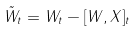Convert formula to latex. <formula><loc_0><loc_0><loc_500><loc_500>\tilde { W } _ { t } = W _ { t } - [ W , X ] _ { t }</formula> 